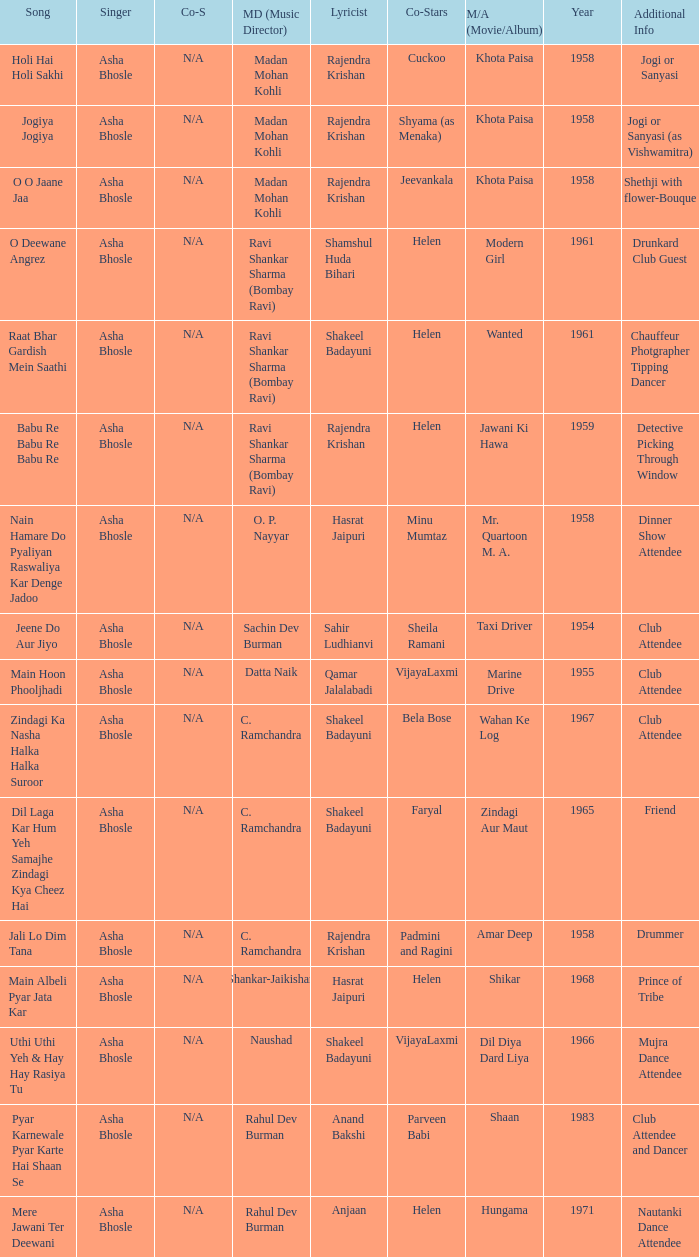How many co-singers were there when Parveen Babi co-starred? 1.0. 